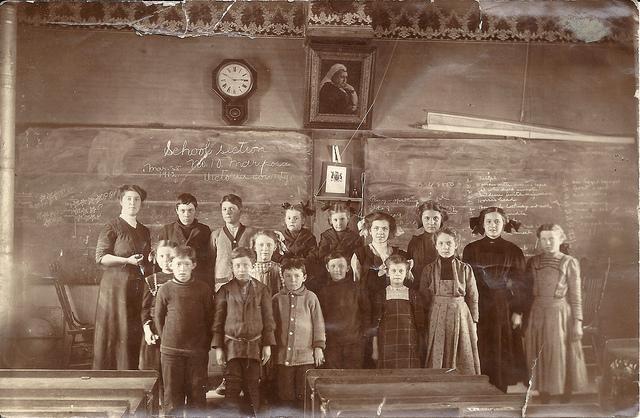How many people are in the photo?
Give a very brief answer. 12. How many baby sheep are in the picture?
Give a very brief answer. 0. 